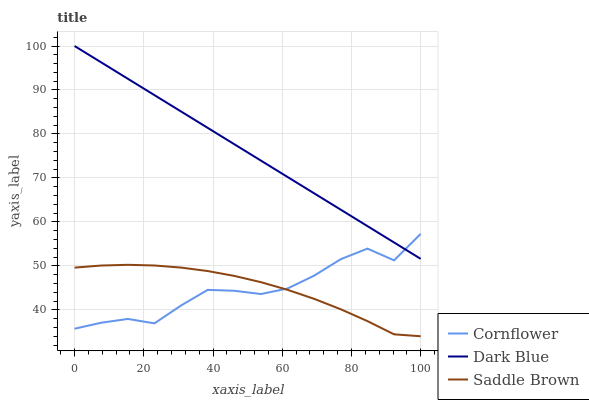Does Cornflower have the minimum area under the curve?
Answer yes or no. Yes. Does Dark Blue have the maximum area under the curve?
Answer yes or no. Yes. Does Saddle Brown have the minimum area under the curve?
Answer yes or no. No. Does Saddle Brown have the maximum area under the curve?
Answer yes or no. No. Is Dark Blue the smoothest?
Answer yes or no. Yes. Is Cornflower the roughest?
Answer yes or no. Yes. Is Saddle Brown the smoothest?
Answer yes or no. No. Is Saddle Brown the roughest?
Answer yes or no. No. Does Dark Blue have the lowest value?
Answer yes or no. No. Does Dark Blue have the highest value?
Answer yes or no. Yes. Does Saddle Brown have the highest value?
Answer yes or no. No. Is Saddle Brown less than Dark Blue?
Answer yes or no. Yes. Is Dark Blue greater than Saddle Brown?
Answer yes or no. Yes. Does Saddle Brown intersect Dark Blue?
Answer yes or no. No. 